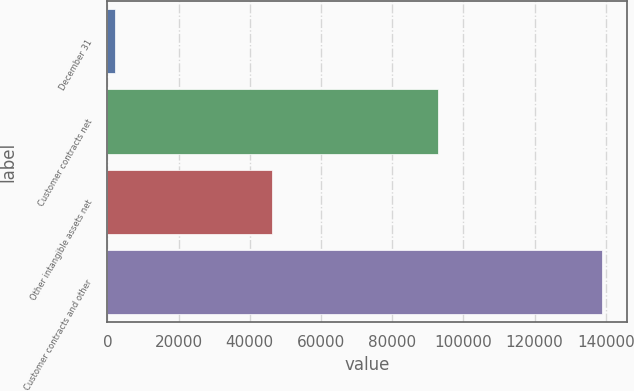<chart> <loc_0><loc_0><loc_500><loc_500><bar_chart><fcel>December 31<fcel>Customer contracts net<fcel>Other intangible assets net<fcel>Customer contracts and other<nl><fcel>2015<fcel>92815<fcel>46116<fcel>138931<nl></chart> 